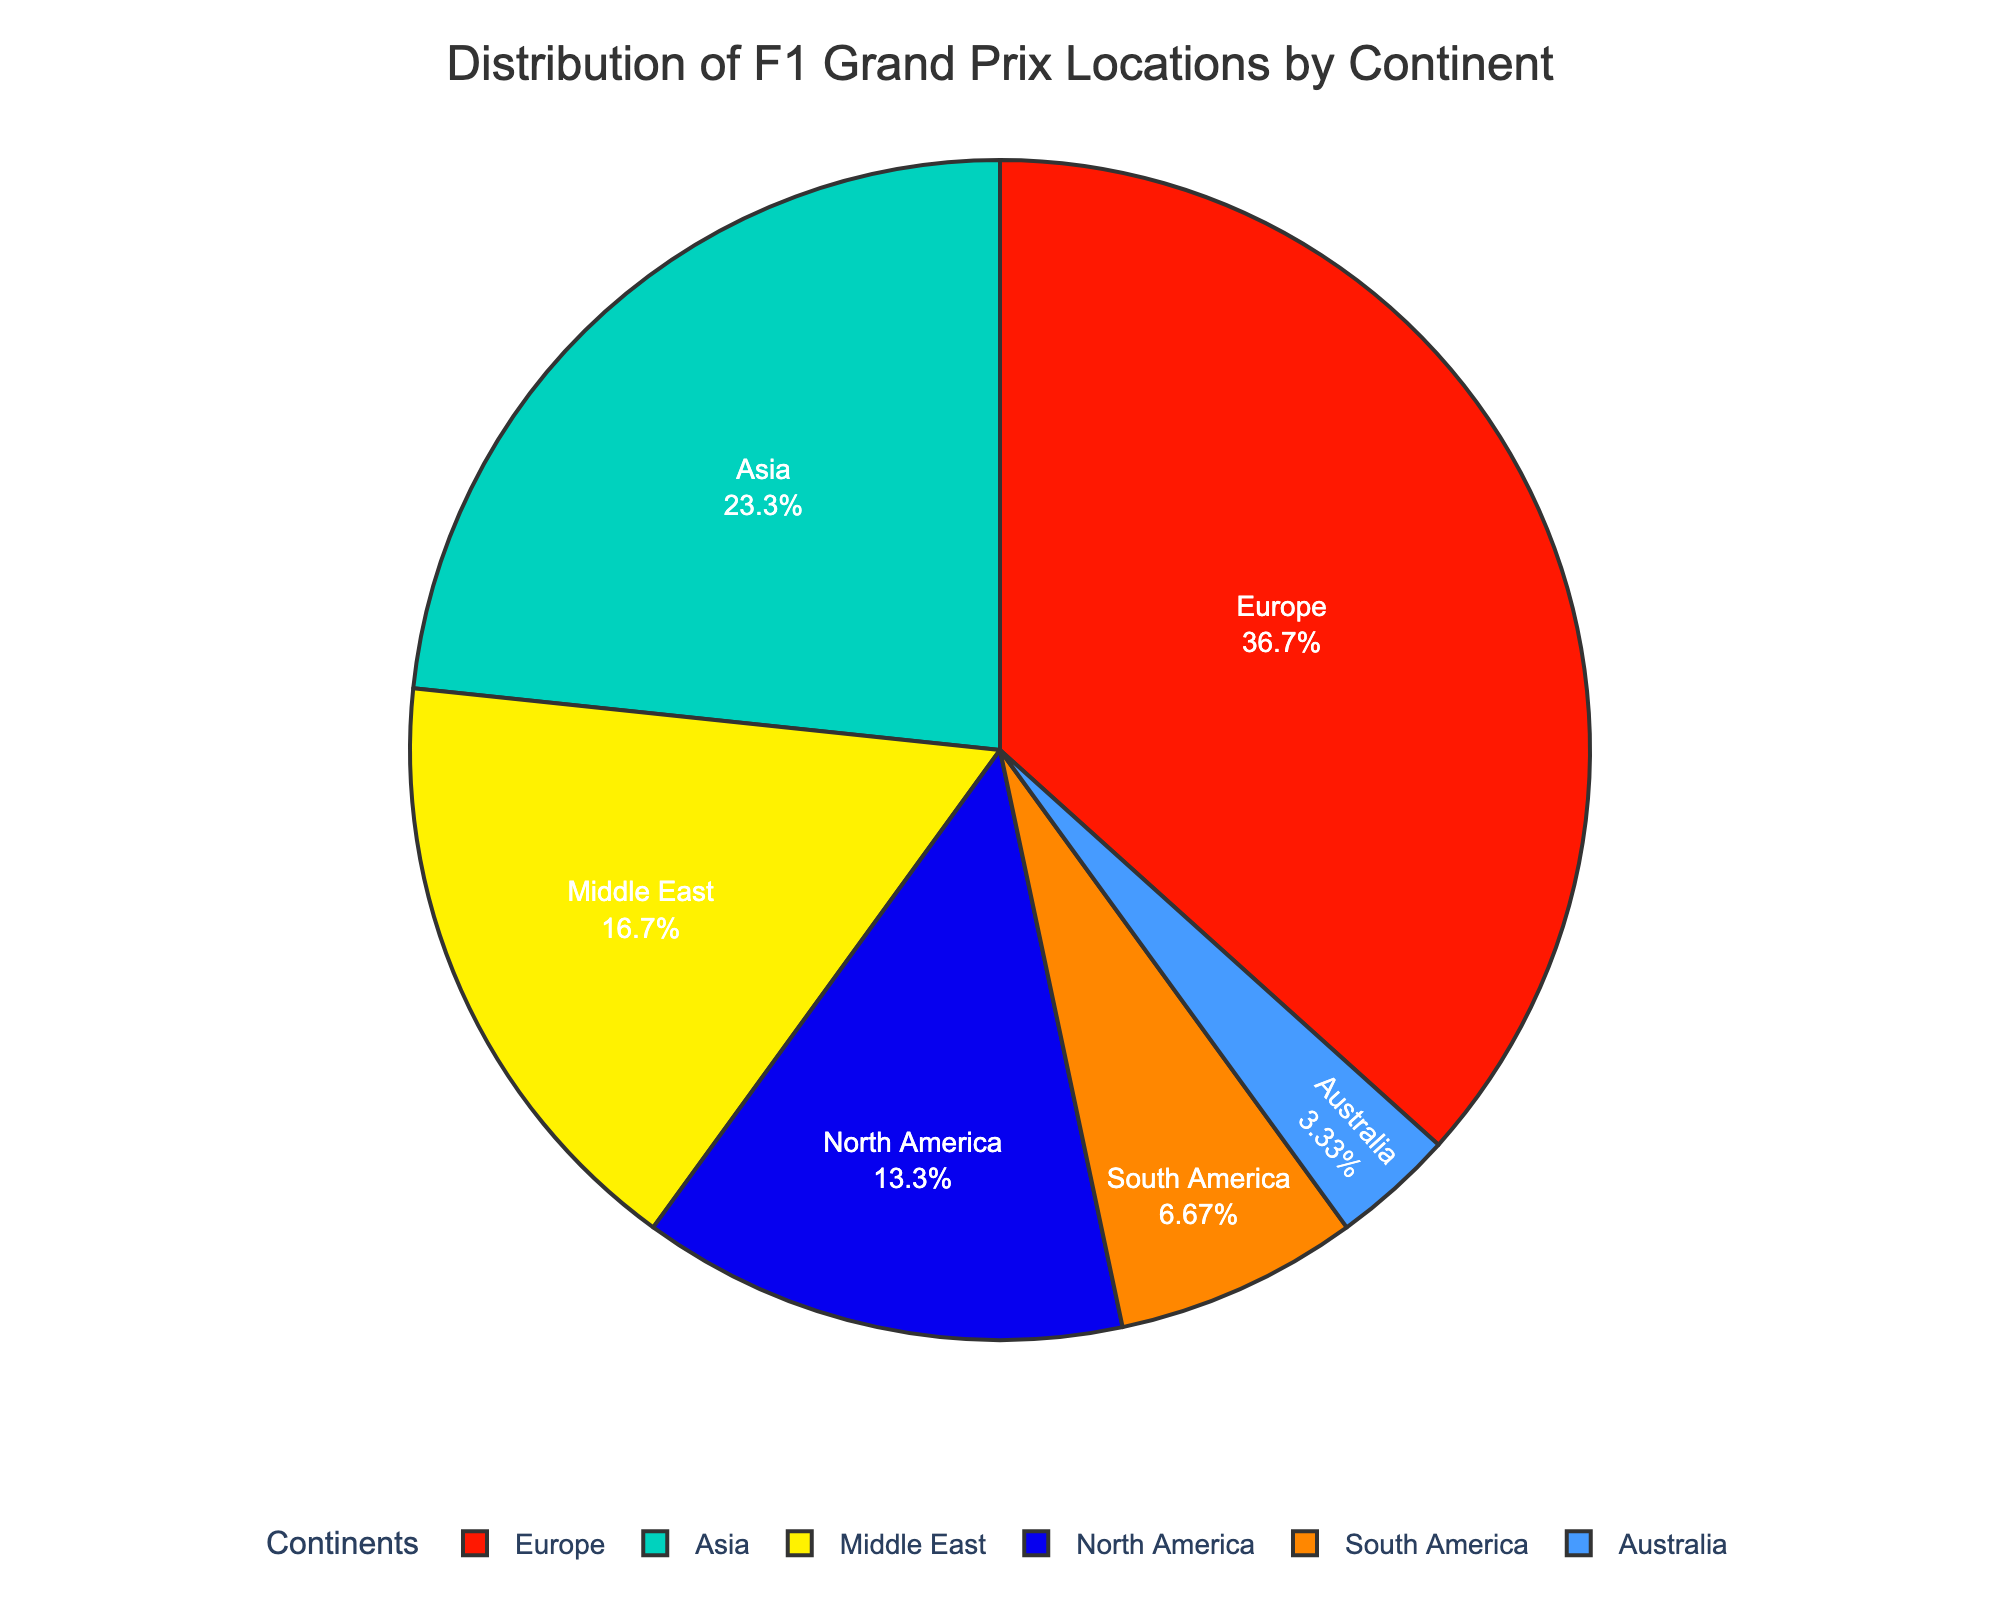Which continent hosts the most Grand Prix in the upcoming season? To answer this question, look at the pie chart and identify the segment with the largest proportion. The continent is Europe, which hosts 11 Grand Prix races.
Answer: Europe How many more Grand Prix races does Europe host compared to North America? To determine this, note the number of Grand Prix races in Europe (11) and North America (4). Subtract the smaller number from the larger number: 11 - 4 = 7.
Answer: 7 What percentage of the total Grand Prix races are held in South America? Sum all the Grand Prix races to get the total number: 11 + 7 + 4 + 2 + 1 + 5 = 30. Then, divide the number of races in South America (2) by the total (30) and multiply by 100 to get the percentage: (2 / 30) * 100 ≈ 6.67%.
Answer: 6.67% Which continents have fewer Grand Prix races than the Middle East? The Middle East hosts 5 races. Identify the continents with fewer than 5 races: South America (2) and Australia (1).
Answer: South America, Australia What is the combined percentage of the Grand Prix races held in Europe and Asia? First, find the total number of races: 30. Sum the races in Europe (11) and Asia (7): 11 + 7 = 18. Then, calculate the percentage: (18 / 30) * 100 = 60%.
Answer: 60% Are there more Grand Prix races in the Middle East than in Australia and South America combined? The Middle East has 5 races, while Australia has 1 and South America has 2. Sum Australia and South America: 1 + 2 = 3. Compare 5 to 3. The Middle East hosts more.
Answer: Yes Which segment of the pie chart is colored green? Look at the color legend. The green segment represents Asia, with 7 Grand Prix races.
Answer: Asia By how much does the number of races in Europe exceed the combined number of races in South America and Oceania? Europe has 11 races. South America has 2 and Oceania (Australia) has 1. Sum South America and Australia: 2 + 1 = 3. Subtract this from Europe's races: 11 - 3 = 8.
Answer: 8 Which continent has the smallest percentage of Grand Prix races? Identify the smallest segment in the pie chart. Australia, with only 1 race, represents the smallest percentage.
Answer: Australia 